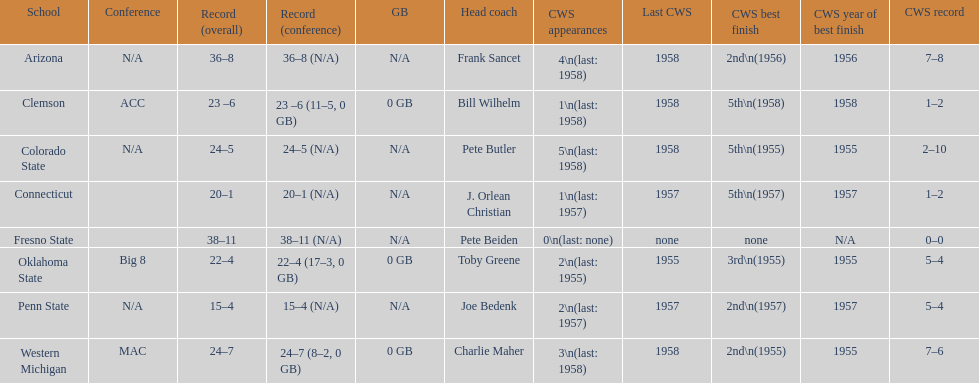Oklahoma state and penn state both have how many cws appearances? 2. 